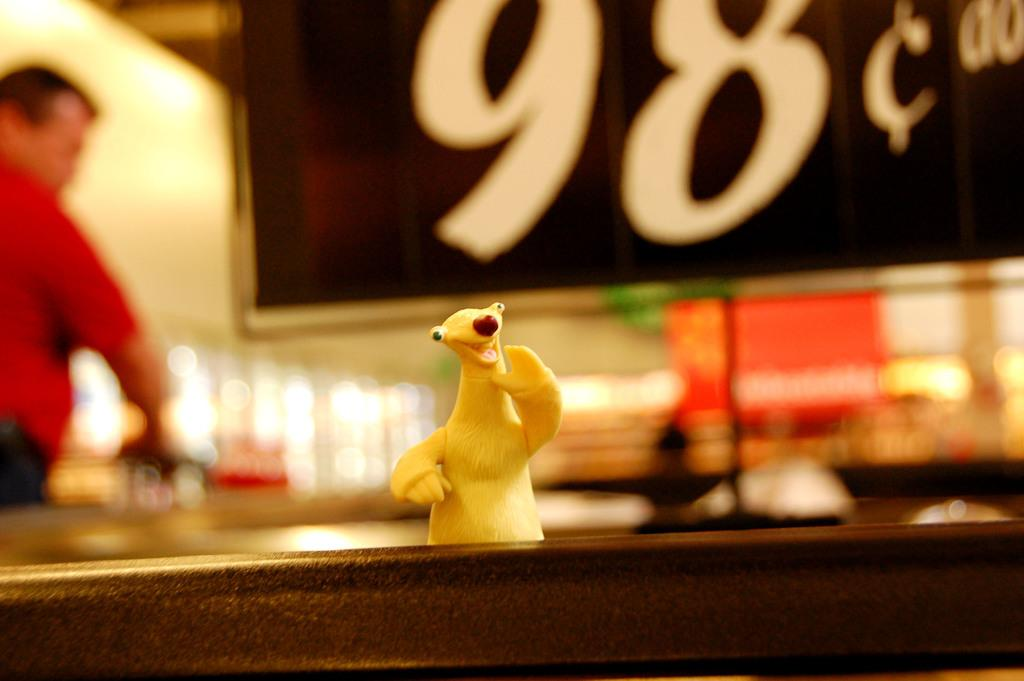What color is the toy in the picture? The toy in the picture is yellow. Where is the yellow toy located? The toy is on a table. What is written on the board in the background of the table? The number 98 is written on the board in the background of the table. What is the man in the picture wearing? The man in the picture is wearing a red t-shirt. How many deer can be seen in the picture? There are no deer present in the picture. What type of sofa is visible in the picture? There is no sofa present in the picture. 